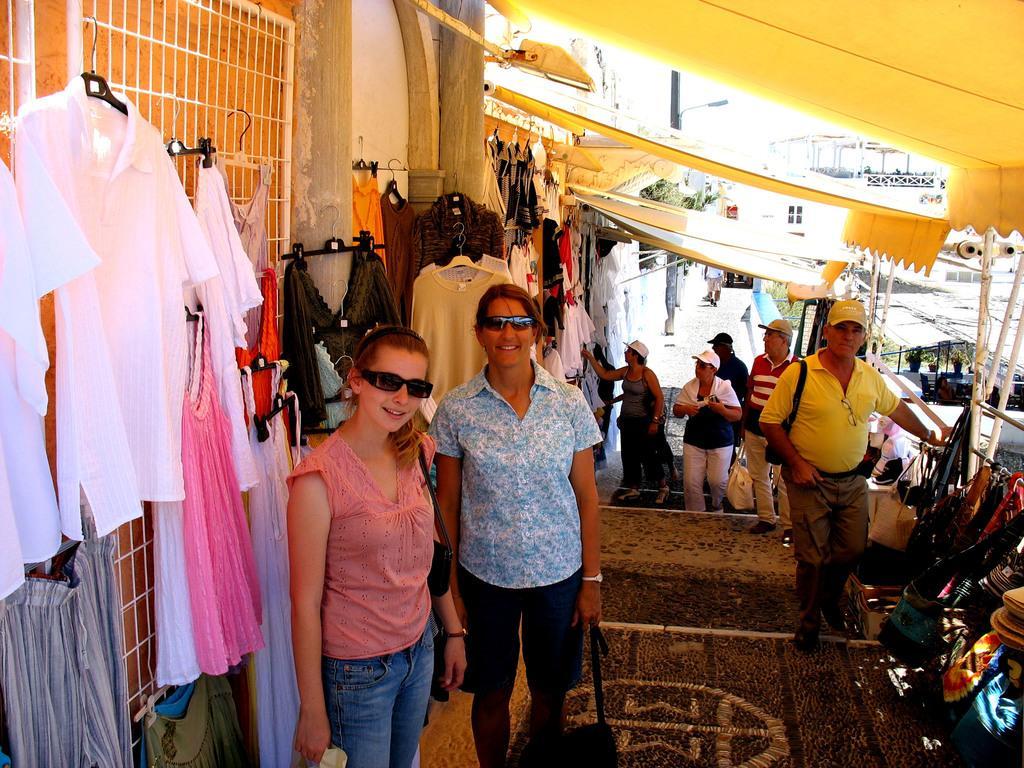Please provide a concise description of this image. In the picture we can see some people are standing on the path near the clothes shop which the clothes are hung to the wall and in the background also we can see some people are standing on the path and wearing the caps and we can see the sheds and building walls. 